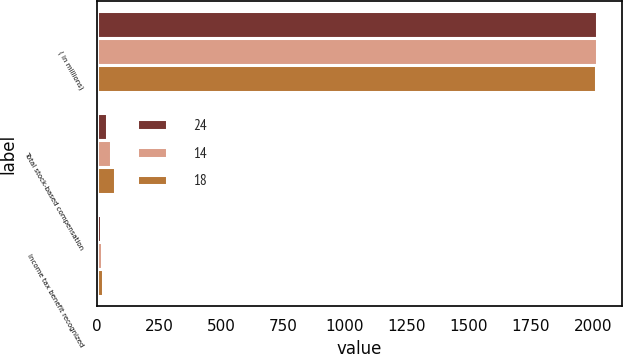<chart> <loc_0><loc_0><loc_500><loc_500><stacked_bar_chart><ecel><fcel>( in millions)<fcel>Total stock-based compensation<fcel>Income tax benefit recognized<nl><fcel>24<fcel>2016<fcel>39<fcel>14<nl><fcel>14<fcel>2015<fcel>54<fcel>18<nl><fcel>18<fcel>2014<fcel>71<fcel>24<nl></chart> 